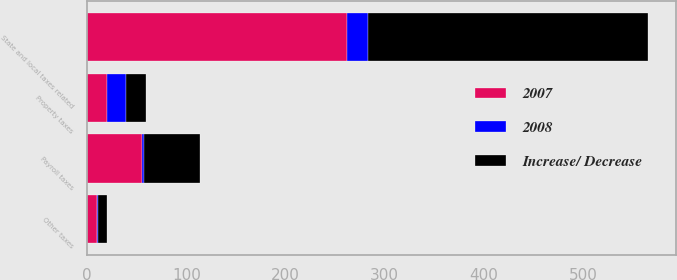Convert chart. <chart><loc_0><loc_0><loc_500><loc_500><stacked_bar_chart><ecel><fcel>Property taxes<fcel>State and local taxes related<fcel>Payroll taxes<fcel>Other taxes<nl><fcel>Increase/ Decrease<fcel>20<fcel>283<fcel>57<fcel>9<nl><fcel>2007<fcel>20<fcel>262<fcel>55<fcel>10<nl><fcel>2008<fcel>19<fcel>21<fcel>2<fcel>1<nl></chart> 